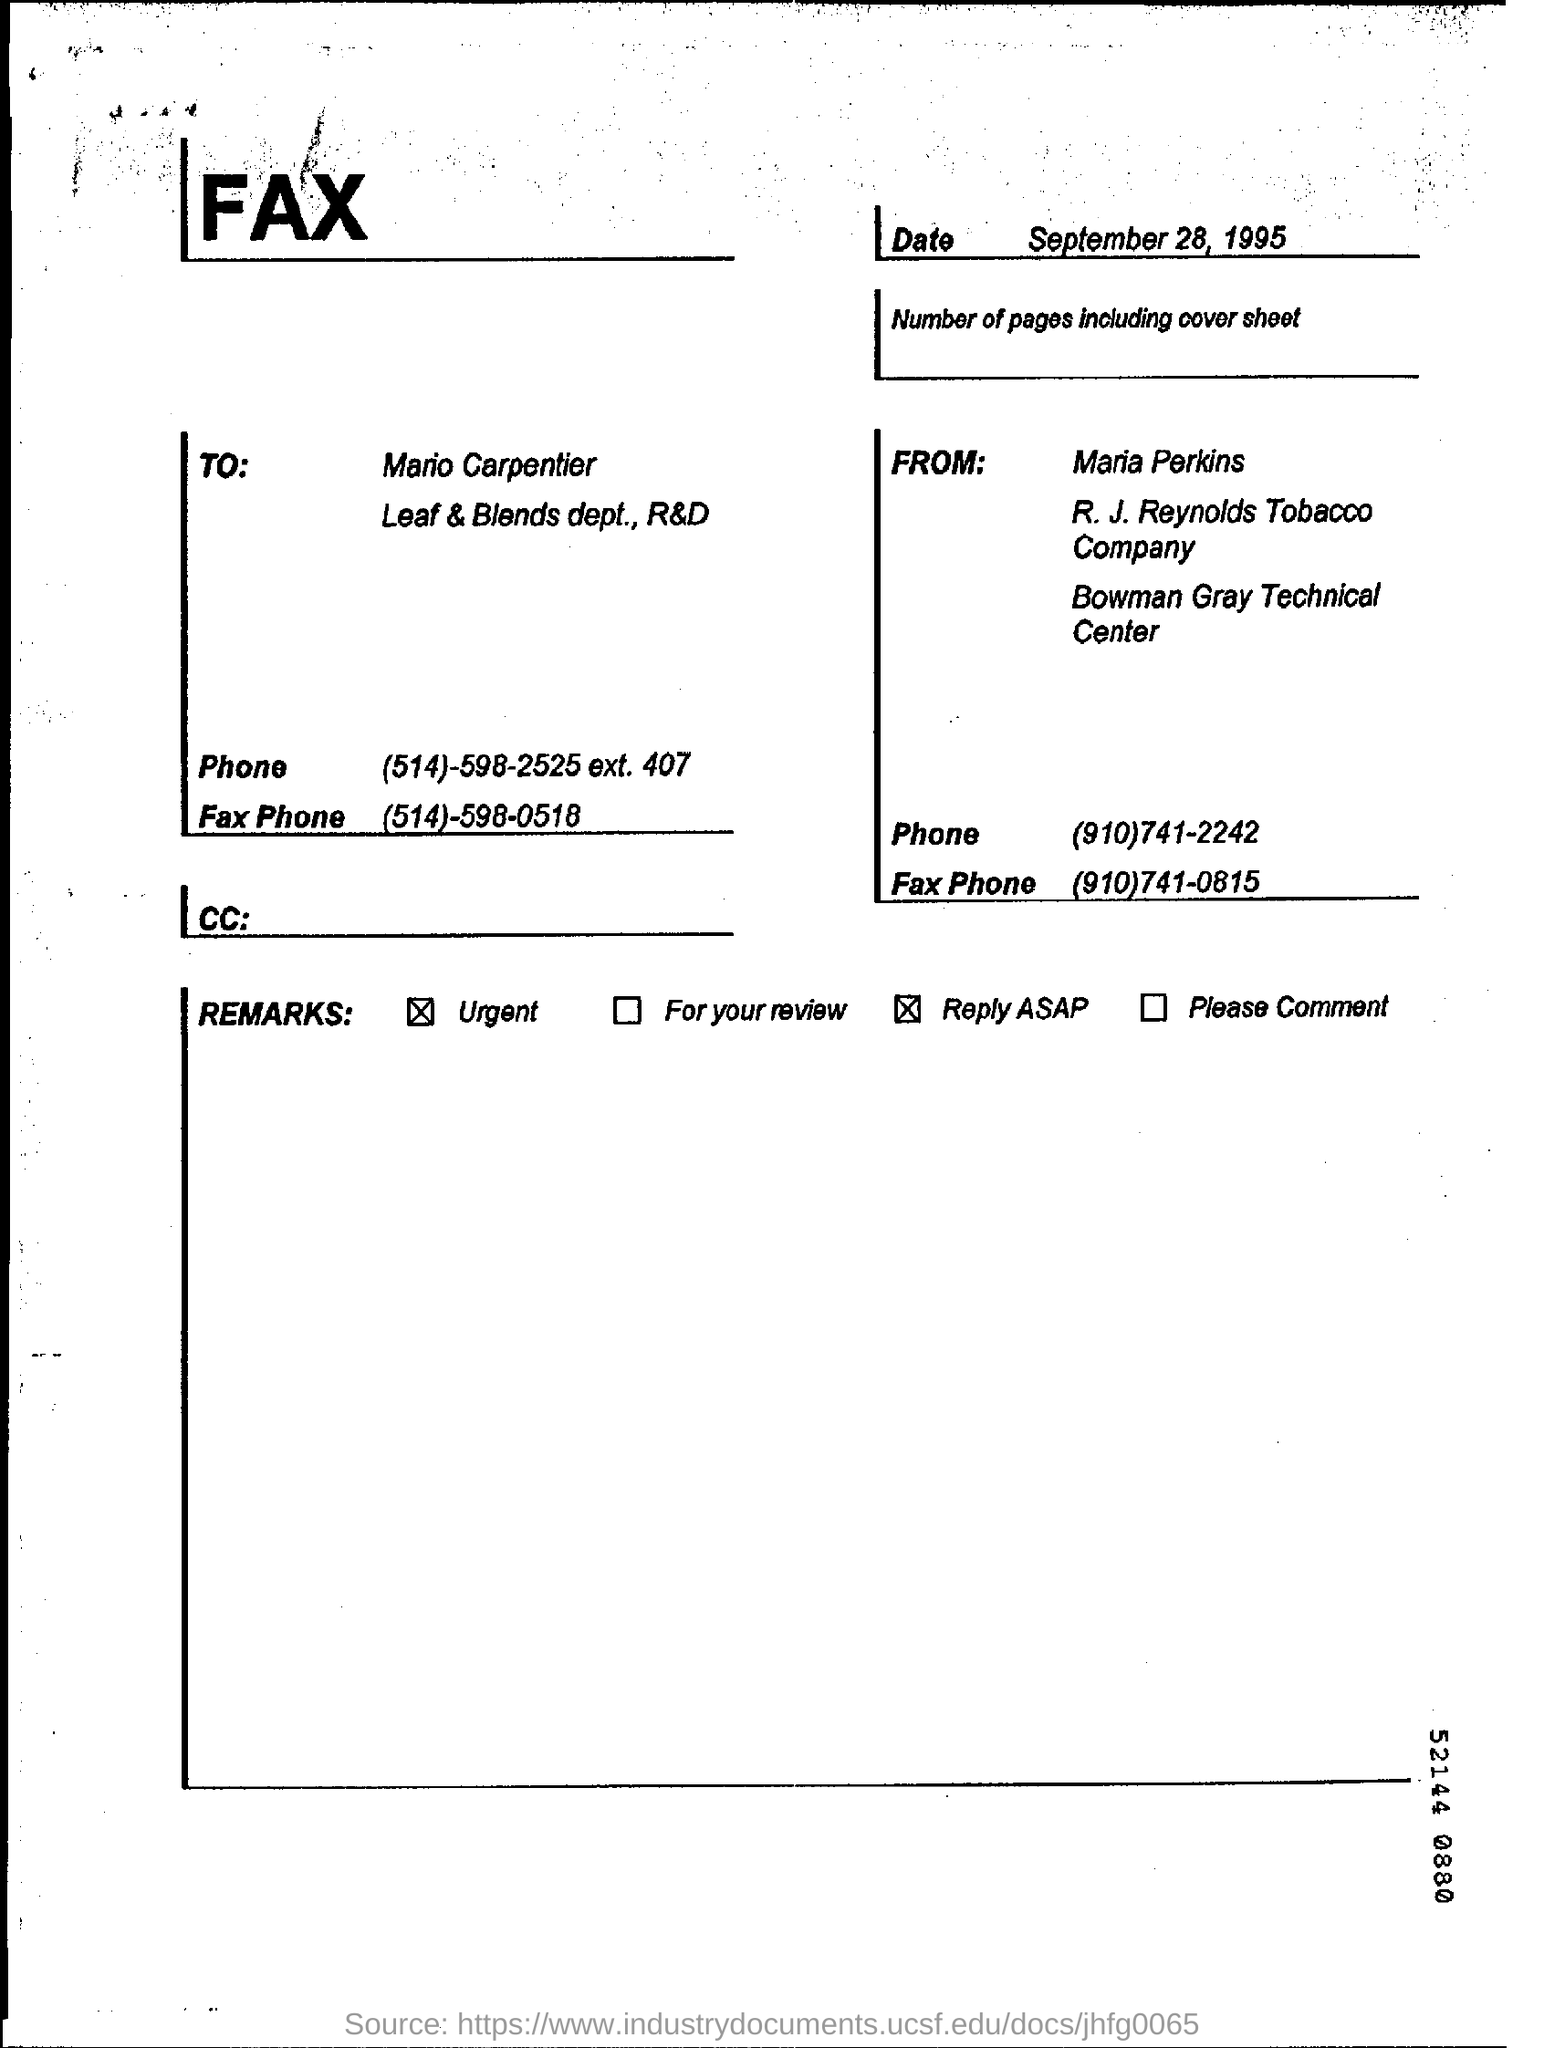What is the date of document?
Offer a terse response. September 28, 1995. 